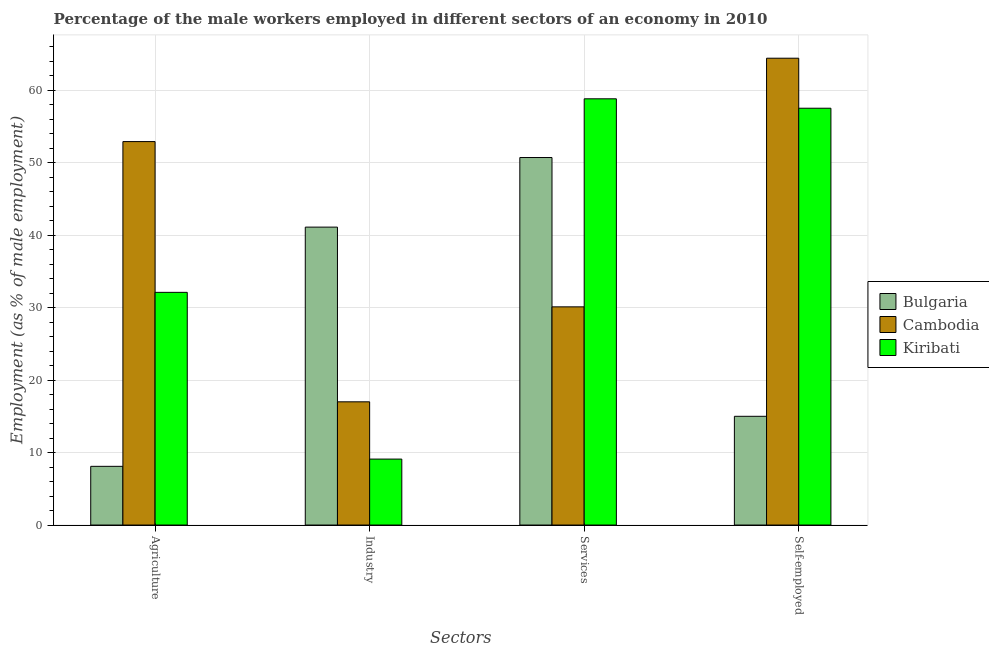How many different coloured bars are there?
Make the answer very short. 3. How many groups of bars are there?
Offer a terse response. 4. Are the number of bars on each tick of the X-axis equal?
Provide a short and direct response. Yes. How many bars are there on the 4th tick from the right?
Provide a short and direct response. 3. What is the label of the 4th group of bars from the left?
Ensure brevity in your answer.  Self-employed. What is the percentage of male workers in industry in Bulgaria?
Your answer should be very brief. 41.1. Across all countries, what is the maximum percentage of male workers in industry?
Provide a succinct answer. 41.1. Across all countries, what is the minimum percentage of male workers in services?
Provide a succinct answer. 30.1. In which country was the percentage of male workers in services maximum?
Give a very brief answer. Kiribati. In which country was the percentage of self employed male workers minimum?
Make the answer very short. Bulgaria. What is the total percentage of male workers in industry in the graph?
Give a very brief answer. 67.2. What is the difference between the percentage of male workers in services in Bulgaria and that in Cambodia?
Ensure brevity in your answer.  20.6. What is the difference between the percentage of male workers in services in Cambodia and the percentage of male workers in agriculture in Bulgaria?
Ensure brevity in your answer.  22. What is the average percentage of self employed male workers per country?
Provide a succinct answer. 45.63. What is the difference between the percentage of male workers in services and percentage of male workers in industry in Kiribati?
Offer a very short reply. 49.7. What is the ratio of the percentage of male workers in services in Bulgaria to that in Kiribati?
Provide a succinct answer. 0.86. Is the percentage of male workers in agriculture in Cambodia less than that in Kiribati?
Your response must be concise. No. What is the difference between the highest and the second highest percentage of male workers in industry?
Give a very brief answer. 24.1. What is the difference between the highest and the lowest percentage of male workers in industry?
Keep it short and to the point. 32. Is the sum of the percentage of male workers in industry in Kiribati and Bulgaria greater than the maximum percentage of self employed male workers across all countries?
Give a very brief answer. No. Is it the case that in every country, the sum of the percentage of male workers in industry and percentage of male workers in services is greater than the sum of percentage of self employed male workers and percentage of male workers in agriculture?
Make the answer very short. No. What does the 3rd bar from the left in Services represents?
Provide a succinct answer. Kiribati. What does the 2nd bar from the right in Industry represents?
Your answer should be compact. Cambodia. How many bars are there?
Offer a terse response. 12. How many countries are there in the graph?
Your answer should be very brief. 3. Does the graph contain any zero values?
Your answer should be very brief. No. How are the legend labels stacked?
Make the answer very short. Vertical. What is the title of the graph?
Ensure brevity in your answer.  Percentage of the male workers employed in different sectors of an economy in 2010. Does "Euro area" appear as one of the legend labels in the graph?
Make the answer very short. No. What is the label or title of the X-axis?
Your response must be concise. Sectors. What is the label or title of the Y-axis?
Make the answer very short. Employment (as % of male employment). What is the Employment (as % of male employment) of Bulgaria in Agriculture?
Provide a succinct answer. 8.1. What is the Employment (as % of male employment) of Cambodia in Agriculture?
Offer a terse response. 52.9. What is the Employment (as % of male employment) in Kiribati in Agriculture?
Keep it short and to the point. 32.1. What is the Employment (as % of male employment) in Bulgaria in Industry?
Provide a succinct answer. 41.1. What is the Employment (as % of male employment) in Cambodia in Industry?
Your answer should be compact. 17. What is the Employment (as % of male employment) of Kiribati in Industry?
Offer a terse response. 9.1. What is the Employment (as % of male employment) in Bulgaria in Services?
Ensure brevity in your answer.  50.7. What is the Employment (as % of male employment) in Cambodia in Services?
Offer a terse response. 30.1. What is the Employment (as % of male employment) in Kiribati in Services?
Your answer should be very brief. 58.8. What is the Employment (as % of male employment) of Bulgaria in Self-employed?
Your answer should be compact. 15. What is the Employment (as % of male employment) in Cambodia in Self-employed?
Your answer should be very brief. 64.4. What is the Employment (as % of male employment) in Kiribati in Self-employed?
Ensure brevity in your answer.  57.5. Across all Sectors, what is the maximum Employment (as % of male employment) of Bulgaria?
Your answer should be compact. 50.7. Across all Sectors, what is the maximum Employment (as % of male employment) in Cambodia?
Provide a succinct answer. 64.4. Across all Sectors, what is the maximum Employment (as % of male employment) of Kiribati?
Your response must be concise. 58.8. Across all Sectors, what is the minimum Employment (as % of male employment) in Bulgaria?
Give a very brief answer. 8.1. Across all Sectors, what is the minimum Employment (as % of male employment) in Cambodia?
Your response must be concise. 17. Across all Sectors, what is the minimum Employment (as % of male employment) in Kiribati?
Your answer should be compact. 9.1. What is the total Employment (as % of male employment) in Bulgaria in the graph?
Offer a terse response. 114.9. What is the total Employment (as % of male employment) of Cambodia in the graph?
Keep it short and to the point. 164.4. What is the total Employment (as % of male employment) of Kiribati in the graph?
Your response must be concise. 157.5. What is the difference between the Employment (as % of male employment) of Bulgaria in Agriculture and that in Industry?
Your answer should be very brief. -33. What is the difference between the Employment (as % of male employment) of Cambodia in Agriculture and that in Industry?
Keep it short and to the point. 35.9. What is the difference between the Employment (as % of male employment) of Kiribati in Agriculture and that in Industry?
Ensure brevity in your answer.  23. What is the difference between the Employment (as % of male employment) of Bulgaria in Agriculture and that in Services?
Keep it short and to the point. -42.6. What is the difference between the Employment (as % of male employment) of Cambodia in Agriculture and that in Services?
Give a very brief answer. 22.8. What is the difference between the Employment (as % of male employment) in Kiribati in Agriculture and that in Services?
Keep it short and to the point. -26.7. What is the difference between the Employment (as % of male employment) of Bulgaria in Agriculture and that in Self-employed?
Give a very brief answer. -6.9. What is the difference between the Employment (as % of male employment) in Kiribati in Agriculture and that in Self-employed?
Ensure brevity in your answer.  -25.4. What is the difference between the Employment (as % of male employment) of Bulgaria in Industry and that in Services?
Offer a terse response. -9.6. What is the difference between the Employment (as % of male employment) in Cambodia in Industry and that in Services?
Offer a very short reply. -13.1. What is the difference between the Employment (as % of male employment) of Kiribati in Industry and that in Services?
Offer a terse response. -49.7. What is the difference between the Employment (as % of male employment) in Bulgaria in Industry and that in Self-employed?
Give a very brief answer. 26.1. What is the difference between the Employment (as % of male employment) in Cambodia in Industry and that in Self-employed?
Give a very brief answer. -47.4. What is the difference between the Employment (as % of male employment) in Kiribati in Industry and that in Self-employed?
Your response must be concise. -48.4. What is the difference between the Employment (as % of male employment) in Bulgaria in Services and that in Self-employed?
Provide a short and direct response. 35.7. What is the difference between the Employment (as % of male employment) in Cambodia in Services and that in Self-employed?
Offer a very short reply. -34.3. What is the difference between the Employment (as % of male employment) in Kiribati in Services and that in Self-employed?
Ensure brevity in your answer.  1.3. What is the difference between the Employment (as % of male employment) of Bulgaria in Agriculture and the Employment (as % of male employment) of Kiribati in Industry?
Offer a very short reply. -1. What is the difference between the Employment (as % of male employment) of Cambodia in Agriculture and the Employment (as % of male employment) of Kiribati in Industry?
Keep it short and to the point. 43.8. What is the difference between the Employment (as % of male employment) of Bulgaria in Agriculture and the Employment (as % of male employment) of Cambodia in Services?
Your answer should be compact. -22. What is the difference between the Employment (as % of male employment) in Bulgaria in Agriculture and the Employment (as % of male employment) in Kiribati in Services?
Your response must be concise. -50.7. What is the difference between the Employment (as % of male employment) of Bulgaria in Agriculture and the Employment (as % of male employment) of Cambodia in Self-employed?
Provide a short and direct response. -56.3. What is the difference between the Employment (as % of male employment) of Bulgaria in Agriculture and the Employment (as % of male employment) of Kiribati in Self-employed?
Provide a succinct answer. -49.4. What is the difference between the Employment (as % of male employment) of Bulgaria in Industry and the Employment (as % of male employment) of Cambodia in Services?
Make the answer very short. 11. What is the difference between the Employment (as % of male employment) in Bulgaria in Industry and the Employment (as % of male employment) in Kiribati in Services?
Your response must be concise. -17.7. What is the difference between the Employment (as % of male employment) in Cambodia in Industry and the Employment (as % of male employment) in Kiribati in Services?
Offer a very short reply. -41.8. What is the difference between the Employment (as % of male employment) of Bulgaria in Industry and the Employment (as % of male employment) of Cambodia in Self-employed?
Offer a very short reply. -23.3. What is the difference between the Employment (as % of male employment) in Bulgaria in Industry and the Employment (as % of male employment) in Kiribati in Self-employed?
Your answer should be compact. -16.4. What is the difference between the Employment (as % of male employment) in Cambodia in Industry and the Employment (as % of male employment) in Kiribati in Self-employed?
Your answer should be very brief. -40.5. What is the difference between the Employment (as % of male employment) in Bulgaria in Services and the Employment (as % of male employment) in Cambodia in Self-employed?
Provide a succinct answer. -13.7. What is the difference between the Employment (as % of male employment) in Bulgaria in Services and the Employment (as % of male employment) in Kiribati in Self-employed?
Provide a short and direct response. -6.8. What is the difference between the Employment (as % of male employment) in Cambodia in Services and the Employment (as % of male employment) in Kiribati in Self-employed?
Offer a terse response. -27.4. What is the average Employment (as % of male employment) in Bulgaria per Sectors?
Provide a short and direct response. 28.73. What is the average Employment (as % of male employment) of Cambodia per Sectors?
Provide a succinct answer. 41.1. What is the average Employment (as % of male employment) in Kiribati per Sectors?
Provide a short and direct response. 39.38. What is the difference between the Employment (as % of male employment) in Bulgaria and Employment (as % of male employment) in Cambodia in Agriculture?
Your answer should be very brief. -44.8. What is the difference between the Employment (as % of male employment) of Cambodia and Employment (as % of male employment) of Kiribati in Agriculture?
Your answer should be very brief. 20.8. What is the difference between the Employment (as % of male employment) in Bulgaria and Employment (as % of male employment) in Cambodia in Industry?
Give a very brief answer. 24.1. What is the difference between the Employment (as % of male employment) in Cambodia and Employment (as % of male employment) in Kiribati in Industry?
Give a very brief answer. 7.9. What is the difference between the Employment (as % of male employment) in Bulgaria and Employment (as % of male employment) in Cambodia in Services?
Offer a terse response. 20.6. What is the difference between the Employment (as % of male employment) in Bulgaria and Employment (as % of male employment) in Kiribati in Services?
Make the answer very short. -8.1. What is the difference between the Employment (as % of male employment) of Cambodia and Employment (as % of male employment) of Kiribati in Services?
Your answer should be very brief. -28.7. What is the difference between the Employment (as % of male employment) in Bulgaria and Employment (as % of male employment) in Cambodia in Self-employed?
Keep it short and to the point. -49.4. What is the difference between the Employment (as % of male employment) in Bulgaria and Employment (as % of male employment) in Kiribati in Self-employed?
Keep it short and to the point. -42.5. What is the difference between the Employment (as % of male employment) of Cambodia and Employment (as % of male employment) of Kiribati in Self-employed?
Provide a short and direct response. 6.9. What is the ratio of the Employment (as % of male employment) of Bulgaria in Agriculture to that in Industry?
Provide a succinct answer. 0.2. What is the ratio of the Employment (as % of male employment) in Cambodia in Agriculture to that in Industry?
Offer a terse response. 3.11. What is the ratio of the Employment (as % of male employment) in Kiribati in Agriculture to that in Industry?
Your response must be concise. 3.53. What is the ratio of the Employment (as % of male employment) in Bulgaria in Agriculture to that in Services?
Keep it short and to the point. 0.16. What is the ratio of the Employment (as % of male employment) in Cambodia in Agriculture to that in Services?
Give a very brief answer. 1.76. What is the ratio of the Employment (as % of male employment) in Kiribati in Agriculture to that in Services?
Provide a short and direct response. 0.55. What is the ratio of the Employment (as % of male employment) in Bulgaria in Agriculture to that in Self-employed?
Make the answer very short. 0.54. What is the ratio of the Employment (as % of male employment) of Cambodia in Agriculture to that in Self-employed?
Your answer should be very brief. 0.82. What is the ratio of the Employment (as % of male employment) of Kiribati in Agriculture to that in Self-employed?
Your answer should be very brief. 0.56. What is the ratio of the Employment (as % of male employment) in Bulgaria in Industry to that in Services?
Your answer should be compact. 0.81. What is the ratio of the Employment (as % of male employment) of Cambodia in Industry to that in Services?
Provide a succinct answer. 0.56. What is the ratio of the Employment (as % of male employment) of Kiribati in Industry to that in Services?
Keep it short and to the point. 0.15. What is the ratio of the Employment (as % of male employment) in Bulgaria in Industry to that in Self-employed?
Ensure brevity in your answer.  2.74. What is the ratio of the Employment (as % of male employment) of Cambodia in Industry to that in Self-employed?
Provide a succinct answer. 0.26. What is the ratio of the Employment (as % of male employment) of Kiribati in Industry to that in Self-employed?
Offer a very short reply. 0.16. What is the ratio of the Employment (as % of male employment) of Bulgaria in Services to that in Self-employed?
Provide a short and direct response. 3.38. What is the ratio of the Employment (as % of male employment) in Cambodia in Services to that in Self-employed?
Offer a very short reply. 0.47. What is the ratio of the Employment (as % of male employment) of Kiribati in Services to that in Self-employed?
Make the answer very short. 1.02. What is the difference between the highest and the second highest Employment (as % of male employment) in Bulgaria?
Keep it short and to the point. 9.6. What is the difference between the highest and the second highest Employment (as % of male employment) of Cambodia?
Your answer should be compact. 11.5. What is the difference between the highest and the lowest Employment (as % of male employment) in Bulgaria?
Keep it short and to the point. 42.6. What is the difference between the highest and the lowest Employment (as % of male employment) in Cambodia?
Ensure brevity in your answer.  47.4. What is the difference between the highest and the lowest Employment (as % of male employment) of Kiribati?
Make the answer very short. 49.7. 